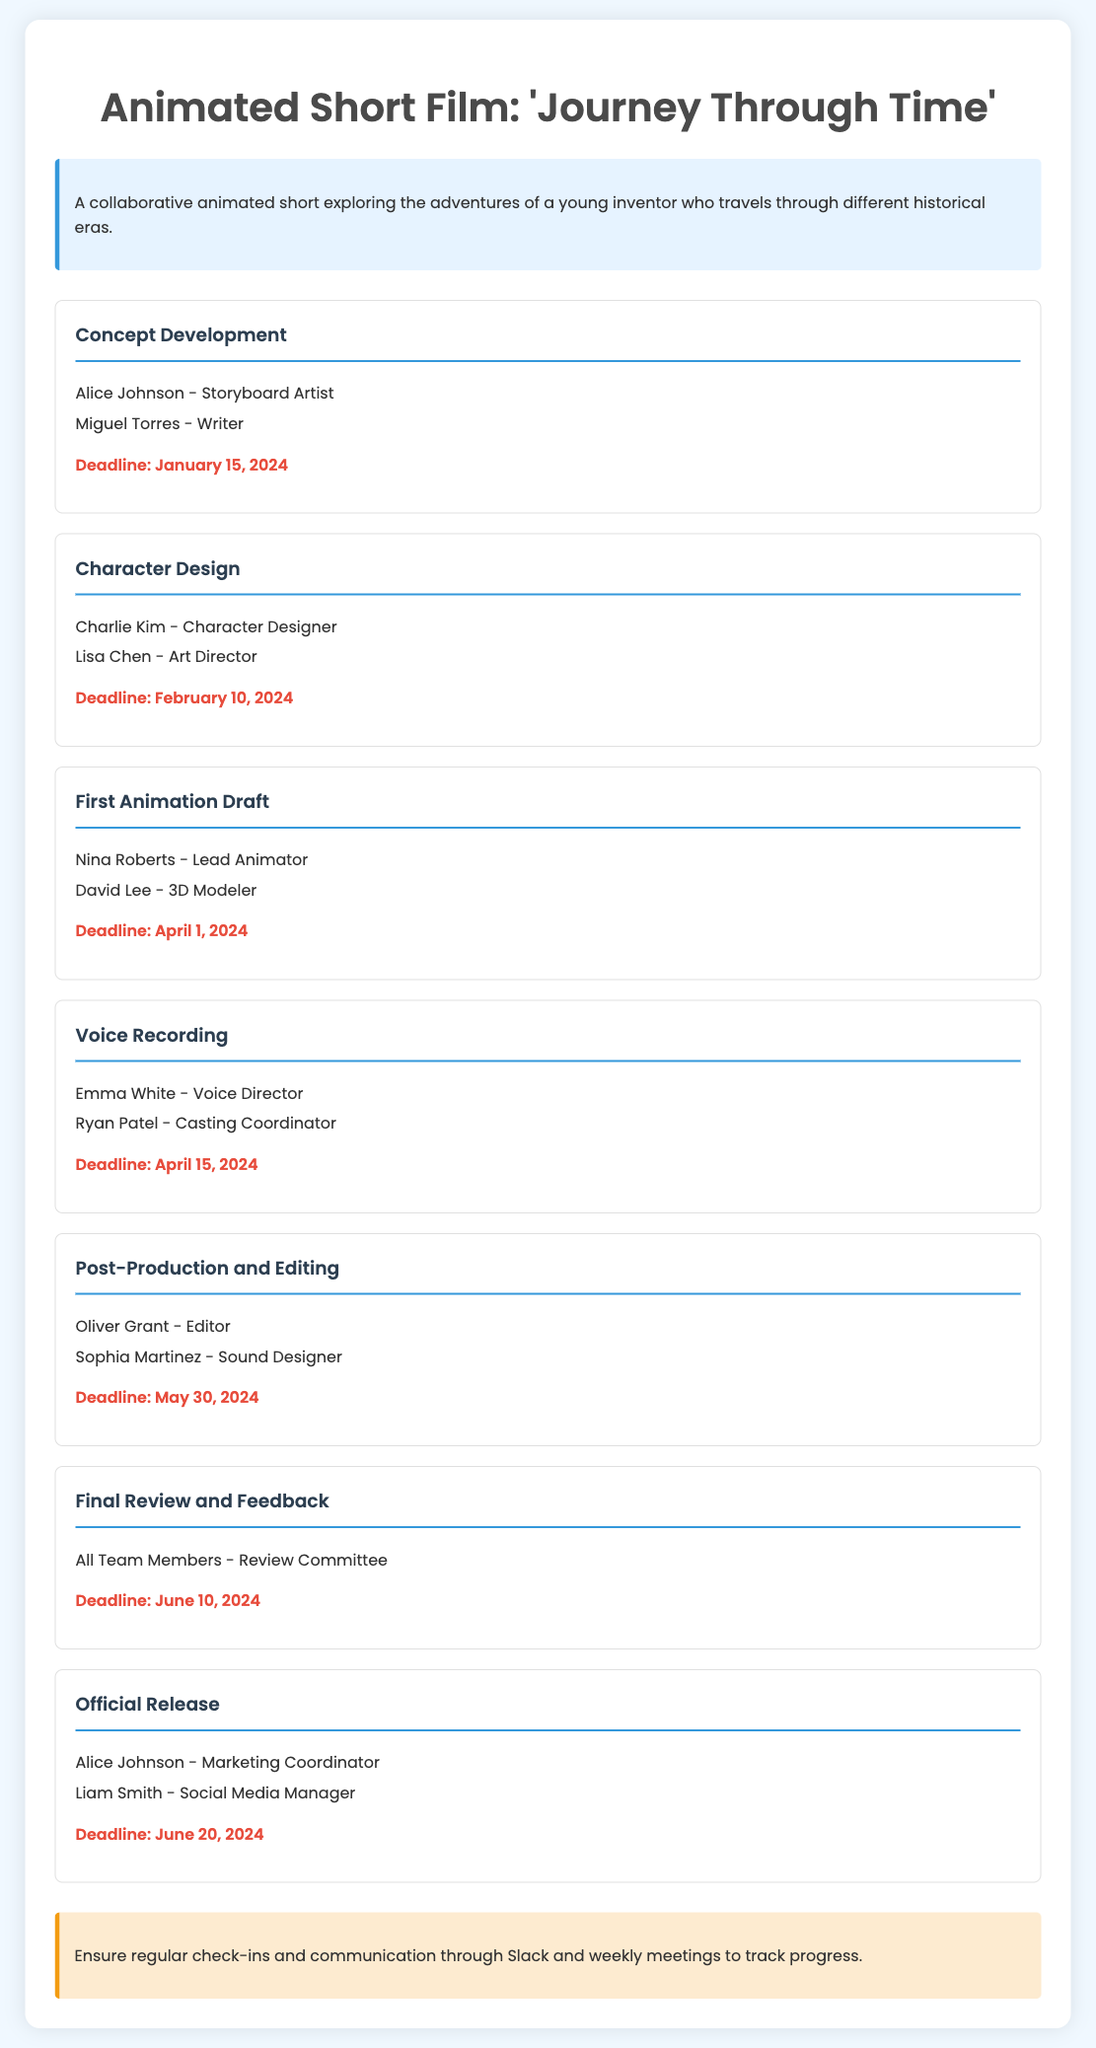What is the title of the project? The title of the project is mentioned prominently at the top of the document.
Answer: Journey Through Time Who is responsible for storyboarding? The responsibilities list for the Concept Development milestone includes the person in charge of storyboarding.
Answer: Alice Johnson What is the deadline for character design? The deadline is clearly stated under the Character Design milestone.
Answer: February 10, 2024 Who directed the voice recording? The person responsible for directing voice recording is listed in the Voice Recording milestone.
Answer: Emma White How many team members are involved in the final review? The responsibilities section of the Final Review and Feedback milestone provides the number of team members involved.
Answer: All Team Members What is the last milestone mentioned in the document? The last milestone listed in the timeline indicates the final stage of the project.
Answer: Official Release What is the role of Liam Smith? Liam Smith's role is found in the responsibilities of the Official Release milestone.
Answer: Social Media Manager When is the deadline for post-production and editing? The specific deadline is listed under the Post-Production and Editing milestone in the document.
Answer: May 30, 2024 What should the team ensure for tracking progress? The notes section suggests a way for the team to keep track of their progress.
Answer: Regular check-ins and communication 